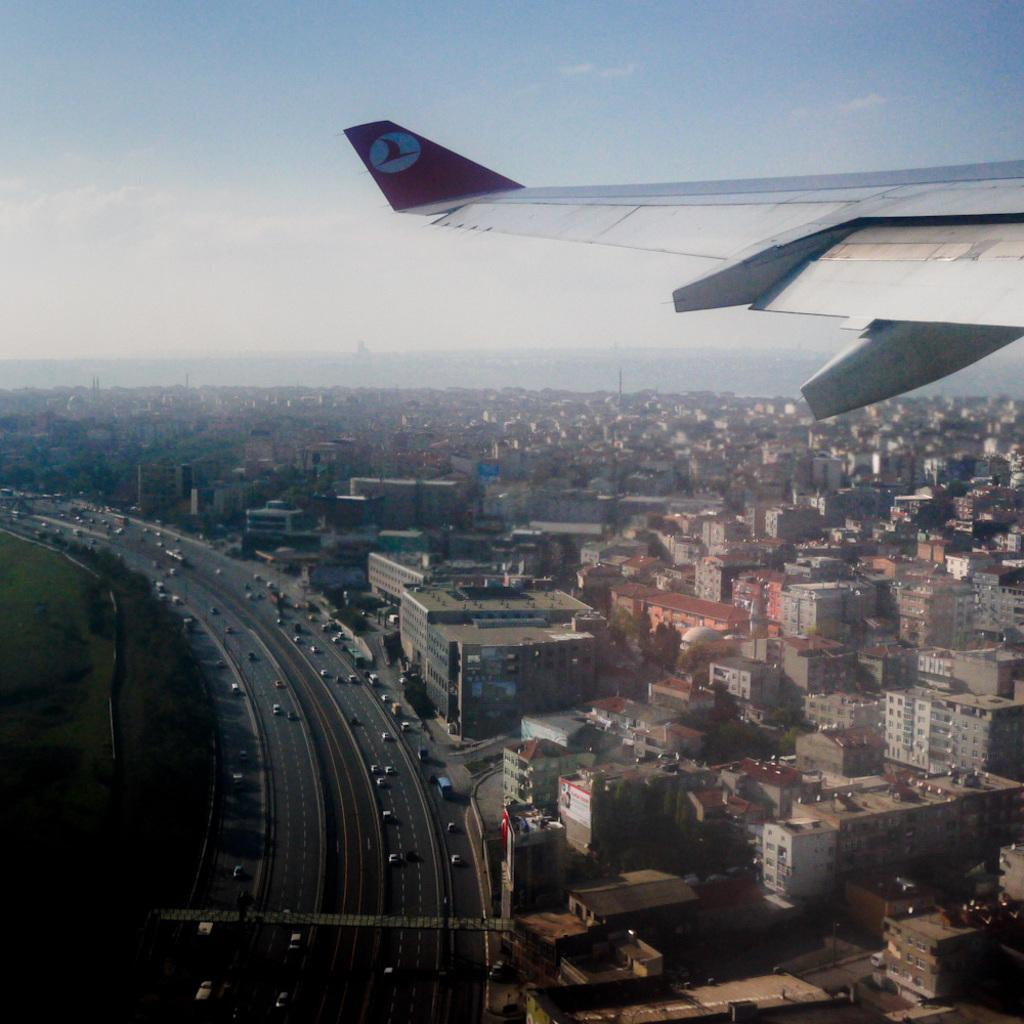What type of structures are present in the image? There are buildings in the image. What mode of transportation can be seen in the image? There is a plane and vehicles in the image. What part of the natural environment is visible in the image? The sky is visible in the image. How would you describe the lighting in the image? The image is a little dark. Where is the hall located in the image? There is no hall present in the image. Is anyone wearing a coat in the image? There is no information about people wearing coats in the image. What rule is being enforced in the image? There is no indication of any rules being enforced in the image. 